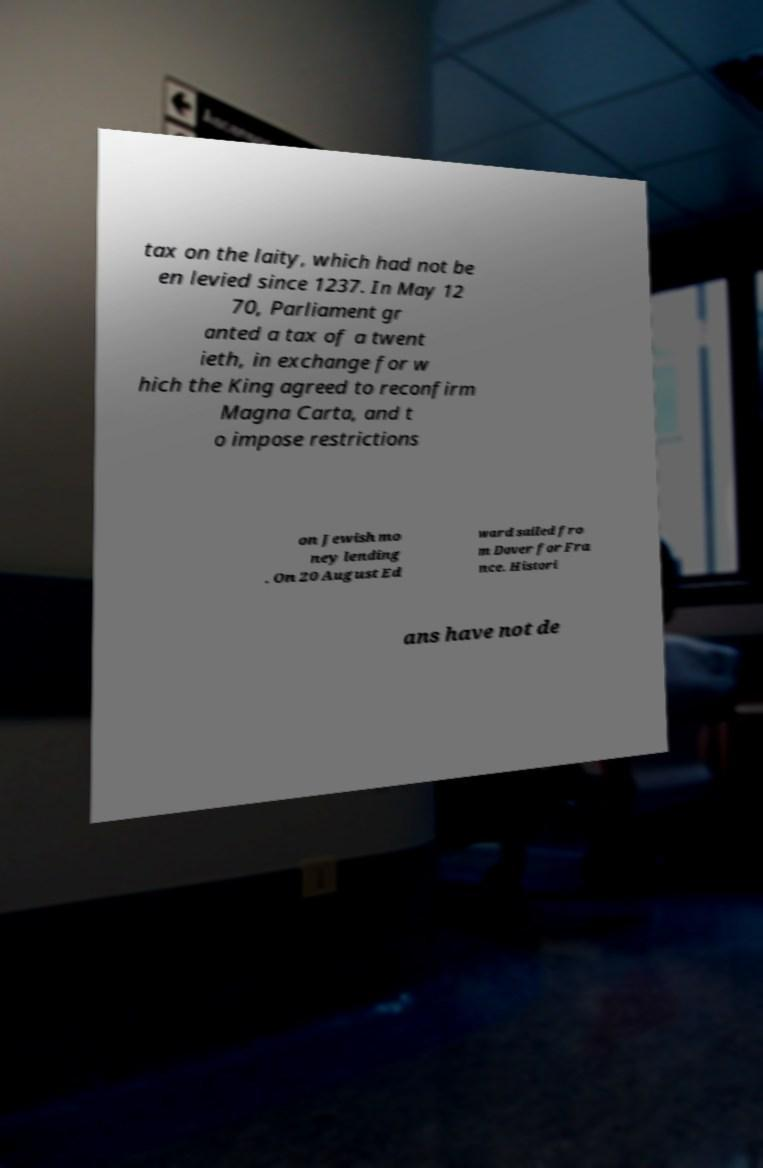Please identify and transcribe the text found in this image. tax on the laity, which had not be en levied since 1237. In May 12 70, Parliament gr anted a tax of a twent ieth, in exchange for w hich the King agreed to reconfirm Magna Carta, and t o impose restrictions on Jewish mo ney lending . On 20 August Ed ward sailed fro m Dover for Fra nce. Histori ans have not de 